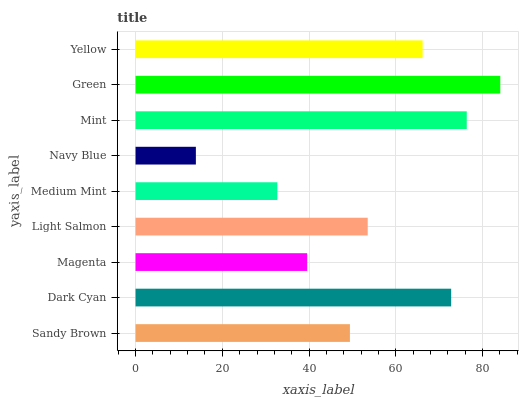Is Navy Blue the minimum?
Answer yes or no. Yes. Is Green the maximum?
Answer yes or no. Yes. Is Dark Cyan the minimum?
Answer yes or no. No. Is Dark Cyan the maximum?
Answer yes or no. No. Is Dark Cyan greater than Sandy Brown?
Answer yes or no. Yes. Is Sandy Brown less than Dark Cyan?
Answer yes or no. Yes. Is Sandy Brown greater than Dark Cyan?
Answer yes or no. No. Is Dark Cyan less than Sandy Brown?
Answer yes or no. No. Is Light Salmon the high median?
Answer yes or no. Yes. Is Light Salmon the low median?
Answer yes or no. Yes. Is Magenta the high median?
Answer yes or no. No. Is Navy Blue the low median?
Answer yes or no. No. 